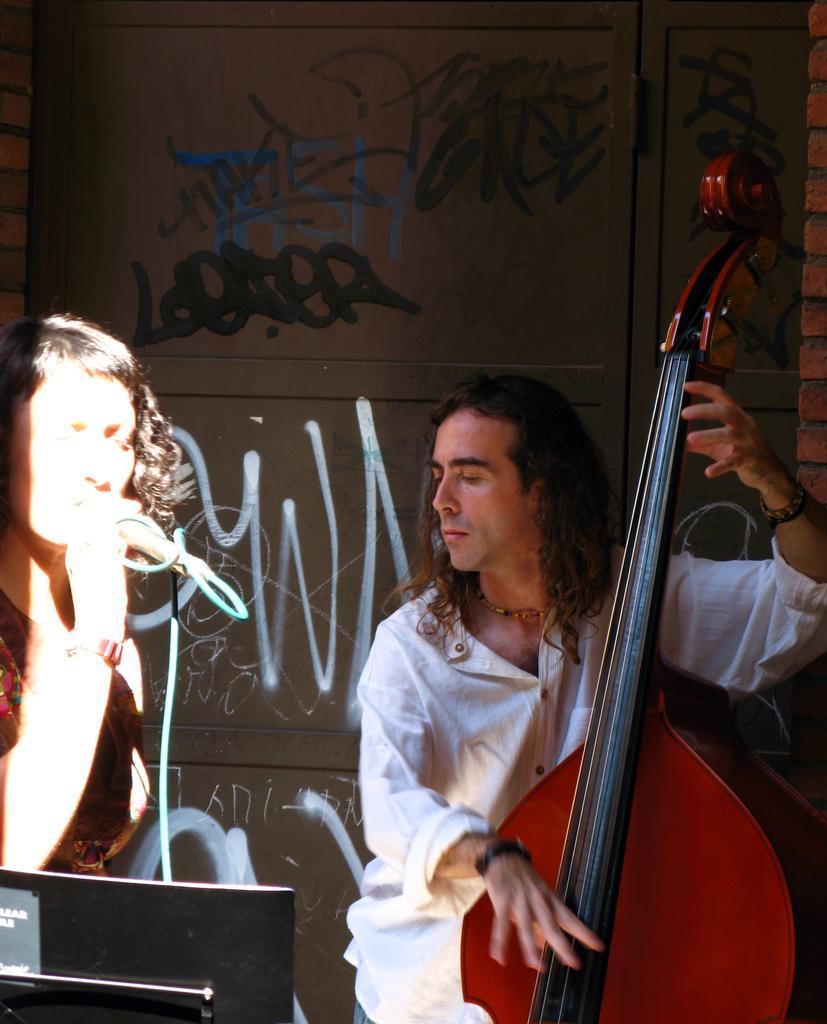Please provide a concise description of this image. Here is a man sitting and playing the musical instrument and the woman is singing a song using a mike. 